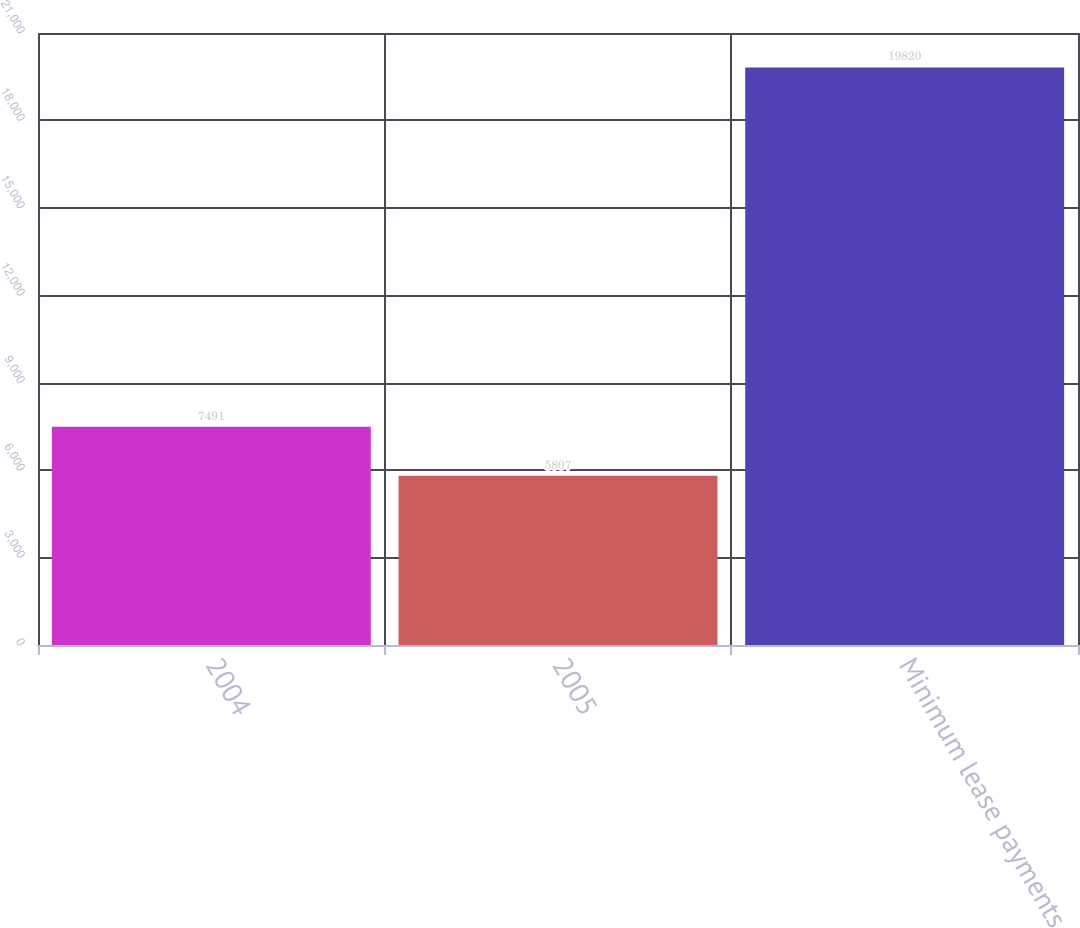<chart> <loc_0><loc_0><loc_500><loc_500><bar_chart><fcel>2004<fcel>2005<fcel>Minimum lease payments<nl><fcel>7491<fcel>5807<fcel>19820<nl></chart> 